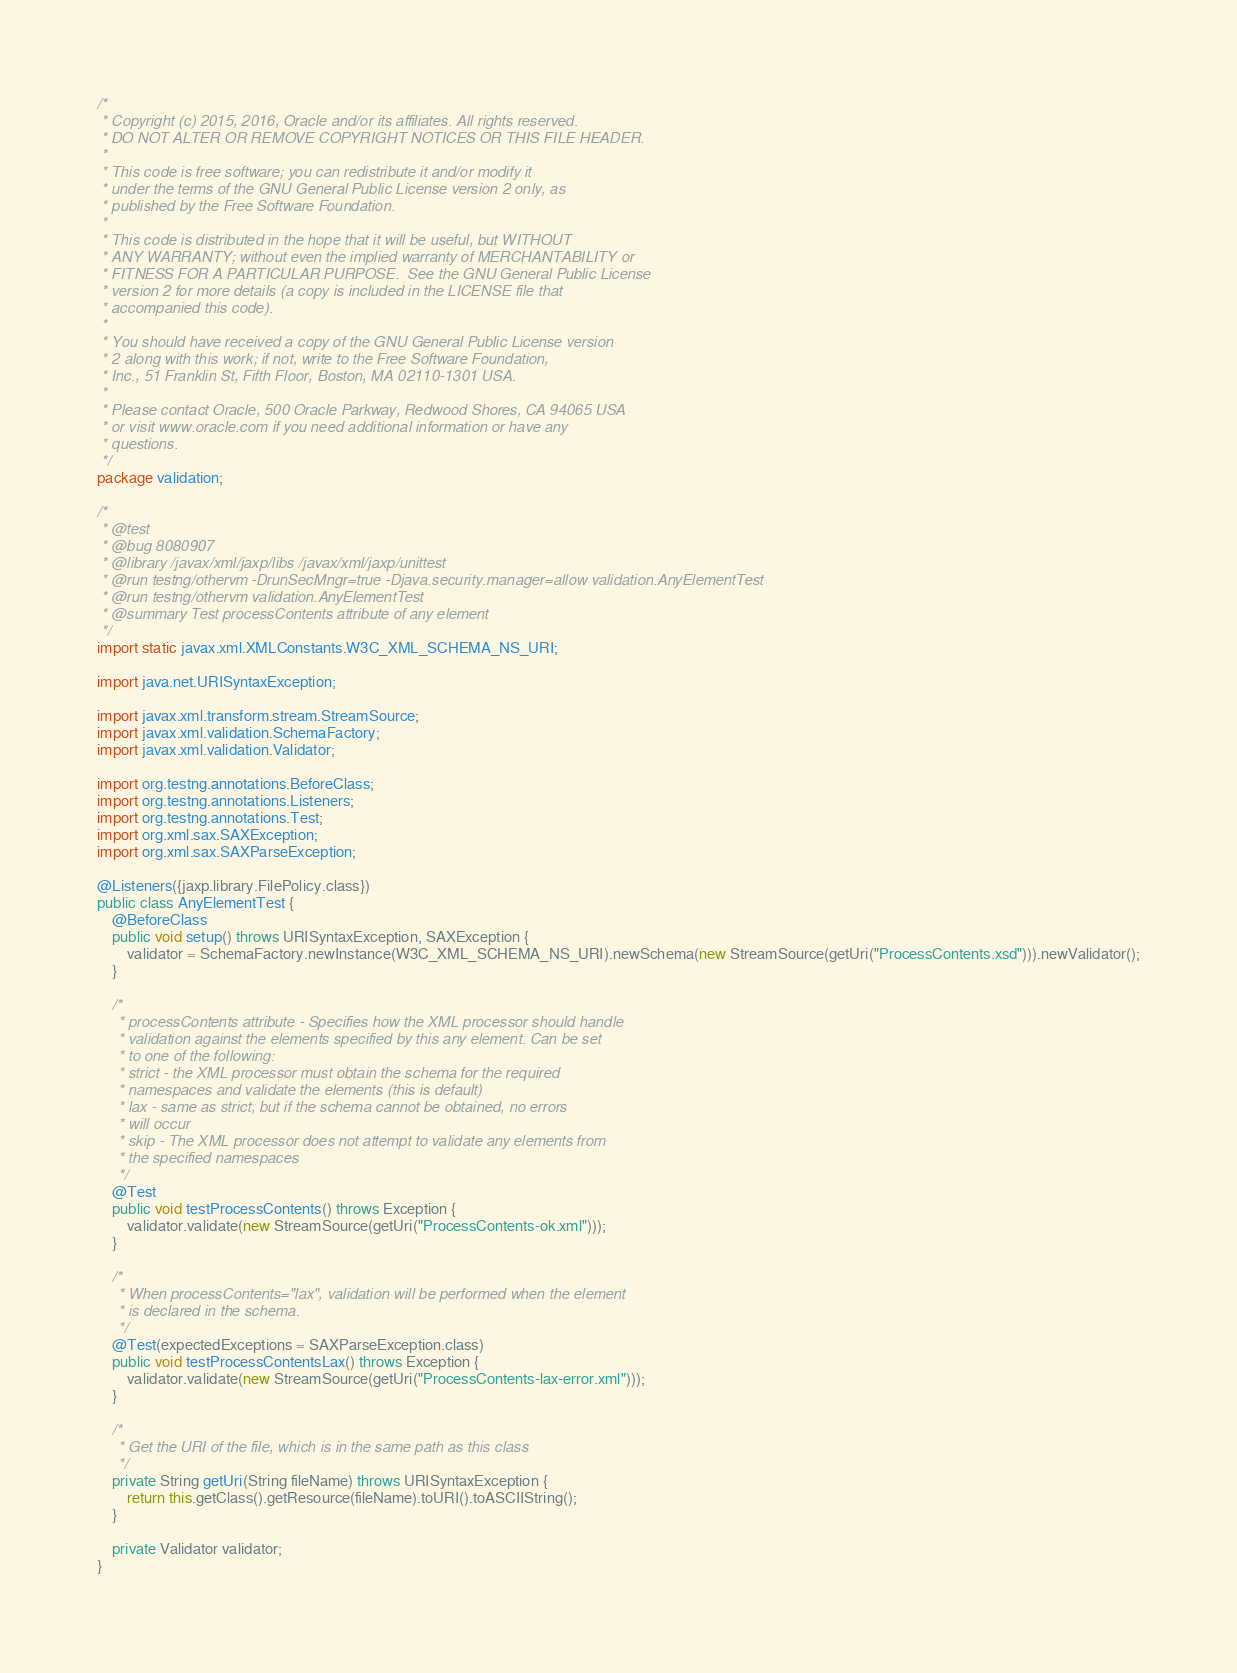Convert code to text. <code><loc_0><loc_0><loc_500><loc_500><_Java_>/*
 * Copyright (c) 2015, 2016, Oracle and/or its affiliates. All rights reserved.
 * DO NOT ALTER OR REMOVE COPYRIGHT NOTICES OR THIS FILE HEADER.
 *
 * This code is free software; you can redistribute it and/or modify it
 * under the terms of the GNU General Public License version 2 only, as
 * published by the Free Software Foundation.
 *
 * This code is distributed in the hope that it will be useful, but WITHOUT
 * ANY WARRANTY; without even the implied warranty of MERCHANTABILITY or
 * FITNESS FOR A PARTICULAR PURPOSE.  See the GNU General Public License
 * version 2 for more details (a copy is included in the LICENSE file that
 * accompanied this code).
 *
 * You should have received a copy of the GNU General Public License version
 * 2 along with this work; if not, write to the Free Software Foundation,
 * Inc., 51 Franklin St, Fifth Floor, Boston, MA 02110-1301 USA.
 *
 * Please contact Oracle, 500 Oracle Parkway, Redwood Shores, CA 94065 USA
 * or visit www.oracle.com if you need additional information or have any
 * questions.
 */
package validation;

/*
 * @test
 * @bug 8080907
 * @library /javax/xml/jaxp/libs /javax/xml/jaxp/unittest
 * @run testng/othervm -DrunSecMngr=true -Djava.security.manager=allow validation.AnyElementTest
 * @run testng/othervm validation.AnyElementTest
 * @summary Test processContents attribute of any element
 */
import static javax.xml.XMLConstants.W3C_XML_SCHEMA_NS_URI;

import java.net.URISyntaxException;

import javax.xml.transform.stream.StreamSource;
import javax.xml.validation.SchemaFactory;
import javax.xml.validation.Validator;

import org.testng.annotations.BeforeClass;
import org.testng.annotations.Listeners;
import org.testng.annotations.Test;
import org.xml.sax.SAXException;
import org.xml.sax.SAXParseException;

@Listeners({jaxp.library.FilePolicy.class})
public class AnyElementTest {
    @BeforeClass
    public void setup() throws URISyntaxException, SAXException {
        validator = SchemaFactory.newInstance(W3C_XML_SCHEMA_NS_URI).newSchema(new StreamSource(getUri("ProcessContents.xsd"))).newValidator();
    }

    /*
     * processContents attribute - Specifies how the XML processor should handle
     * validation against the elements specified by this any element. Can be set
     * to one of the following:
     * strict - the XML processor must obtain the schema for the required
     * namespaces and validate the elements (this is default)
     * lax - same as strict, but if the schema cannot be obtained, no errors
     * will occur
     * skip - The XML processor does not attempt to validate any elements from
     * the specified namespaces
     */
    @Test
    public void testProcessContents() throws Exception {
        validator.validate(new StreamSource(getUri("ProcessContents-ok.xml")));
    }

    /*
     * When processContents="lax", validation will be performed when the element
     * is declared in the schema.
     */
    @Test(expectedExceptions = SAXParseException.class)
    public void testProcessContentsLax() throws Exception {
        validator.validate(new StreamSource(getUri("ProcessContents-lax-error.xml")));
    }

    /*
     * Get the URI of the file, which is in the same path as this class
     */
    private String getUri(String fileName) throws URISyntaxException {
        return this.getClass().getResource(fileName).toURI().toASCIIString();
    }

    private Validator validator;
}
</code> 